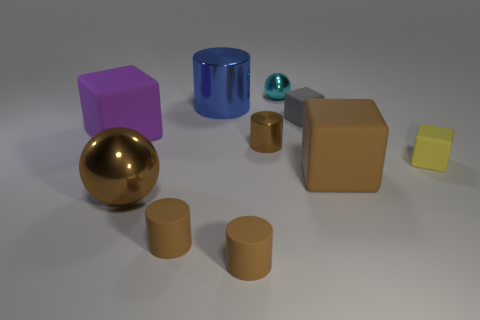Are there an equal number of large brown rubber things behind the yellow cube and rubber cylinders left of the large purple rubber object?
Keep it short and to the point. Yes. Is the large brown object on the right side of the cyan object made of the same material as the big block on the left side of the brown matte block?
Provide a succinct answer. Yes. What number of other objects are there of the same size as the purple block?
Keep it short and to the point. 3. What number of things are balls or shiny things that are in front of the large purple cube?
Make the answer very short. 3. Are there an equal number of large matte cubes on the left side of the blue cylinder and gray rubber objects?
Keep it short and to the point. Yes. What is the shape of the big purple thing that is the same material as the big brown block?
Give a very brief answer. Cube. Is there a big matte thing that has the same color as the big metal ball?
Provide a short and direct response. Yes. What number of rubber things are big blue cylinders or tiny yellow spheres?
Give a very brief answer. 0. There is a shiny object to the left of the large blue metallic object; how many yellow cubes are left of it?
Ensure brevity in your answer.  0. How many tiny brown objects have the same material as the cyan ball?
Give a very brief answer. 1. 